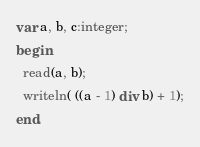<code> <loc_0><loc_0><loc_500><loc_500><_Pascal_>var a, b, c:integer;
begin
  read(a, b);
  writeln( ((a - 1) div b) + 1);
end.</code> 